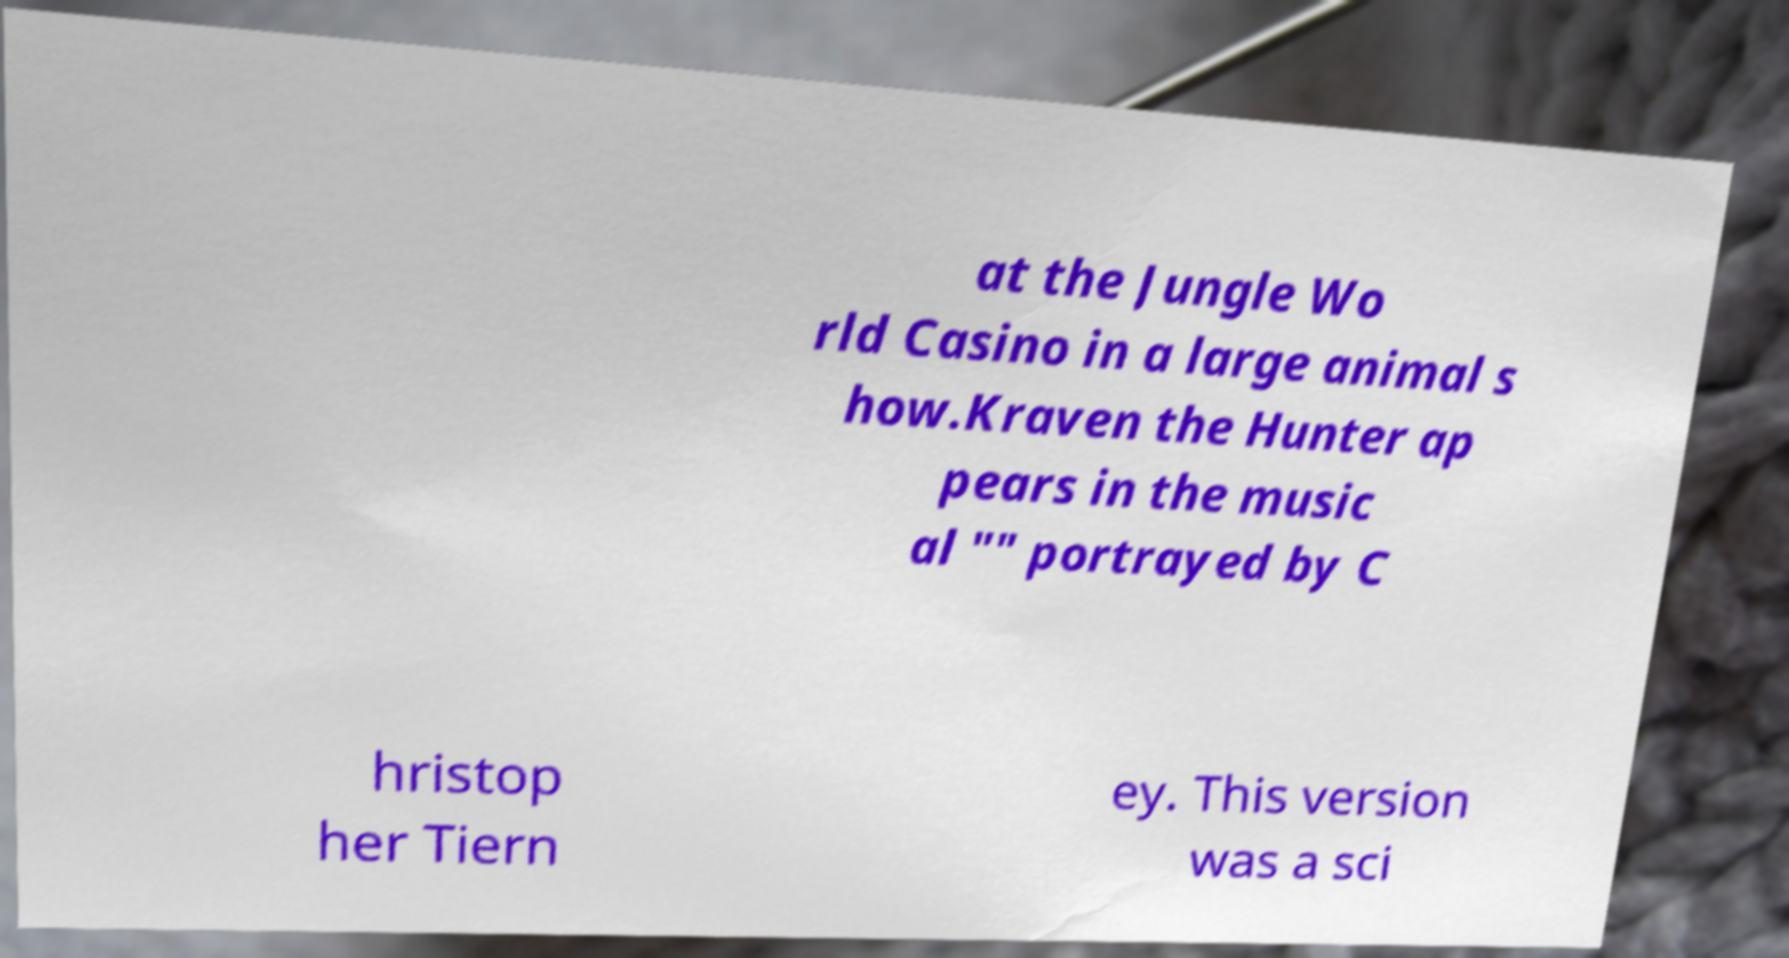Could you assist in decoding the text presented in this image and type it out clearly? at the Jungle Wo rld Casino in a large animal s how.Kraven the Hunter ap pears in the music al "" portrayed by C hristop her Tiern ey. This version was a sci 